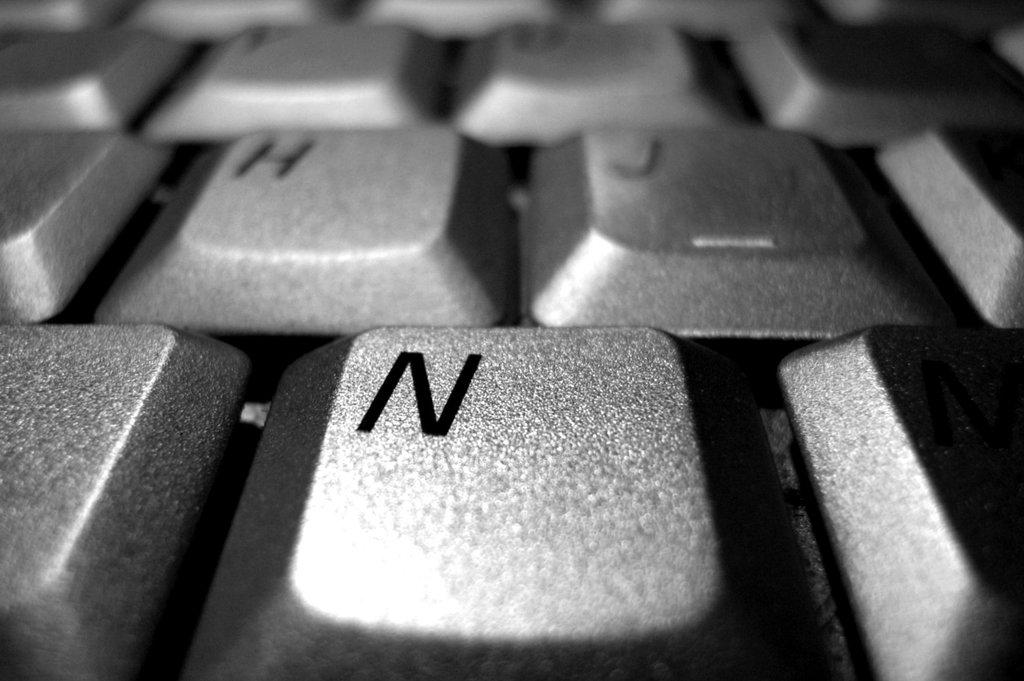What letter is on the key?
Your response must be concise. N. What key is closest and largest from this perspective?
Provide a short and direct response. N. 